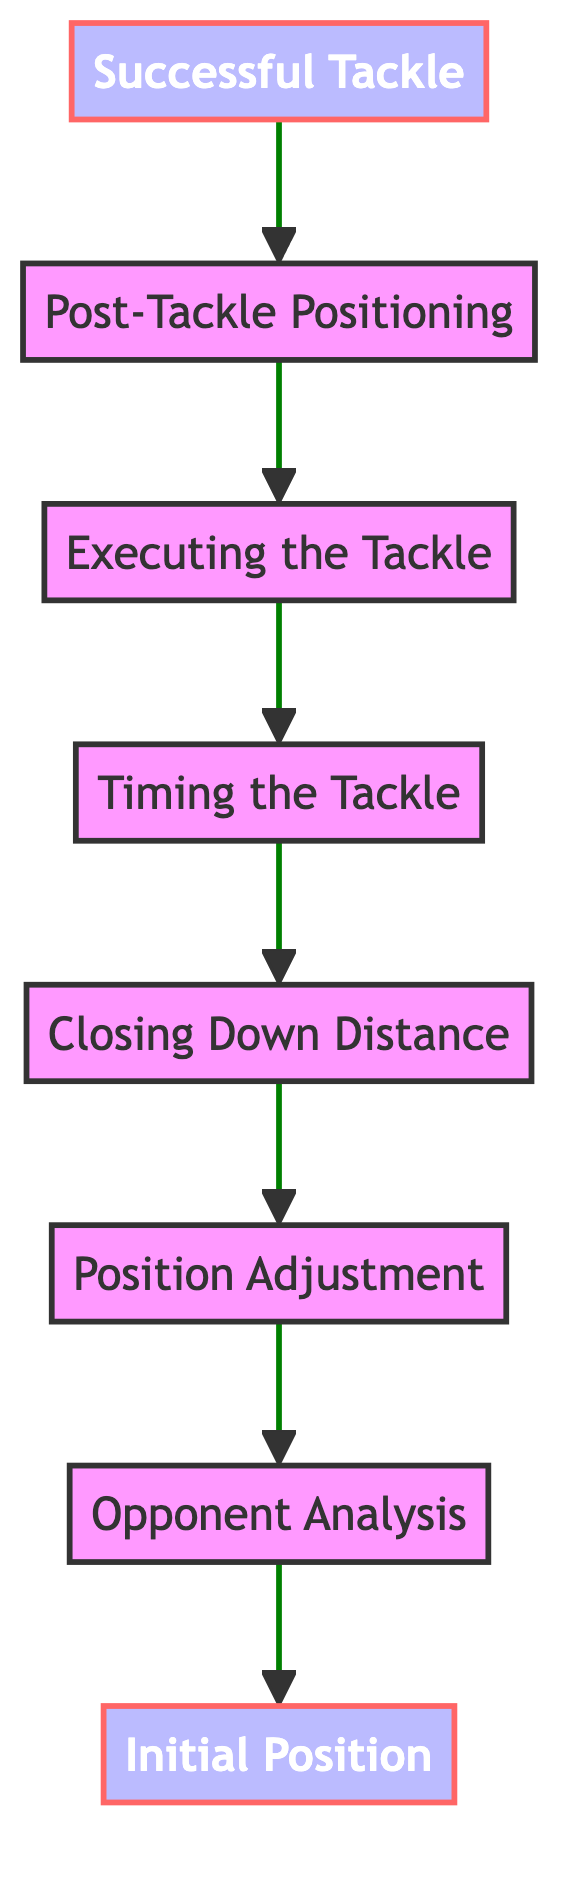What is the first step in the decision tree? The first step in the decision tree is "Initial Position," which represents the starting position of the defender on the pitch.
Answer: Initial Position How many total nodes are in the diagram? The diagram contains a total of 8 nodes, representing each step in the decision-making process from the initial position to the successful tackle.
Answer: 8 What is the last step in the flow chart? The last step in the flow chart is "Successful Tackle," which indicates the completion of a successful defensive action.
Answer: Successful Tackle Which node follows "Executing the Tackle"? "Post-Tackle Positioning" directly follows "Executing the Tackle" in the flow of the diagram.
Answer: Post-Tackle Positioning Explain the progression from "Opponent Analysis" to "Closing Down Distance." After assessing the opponent's tendencies in "Opponent Analysis," the next step is "Position Adjustment." Following that, based on the adjusted position, the defender calculates the "Closing Down Distance," which helps to determine how close they should get to the opponent before making a tackle.
Answer: Closing Down Distance Which two nodes are crucial for performing a successful tackle? The nodes "Timing the Tackle" and "Executing the Tackle" are crucial steps that directly influence the success of the defensive play.
Answer: Timing the Tackle, Executing the Tackle What node directly precedes the "Successful Tackle"? The node that directly precedes "Successful Tackle" is "Post-Tackle Positioning," which ensures the defender maintains the right position after the tackle.
Answer: Post-Tackle Positioning What is the relationship between "Position Adjustment" and "Opponent Analysis"? "Position Adjustment" is dependent on the results of "Opponent Analysis," meaning that the defender adjusts their position based on the analysis of the opponent's movements and tendencies.
Answer: Dependent relationship 